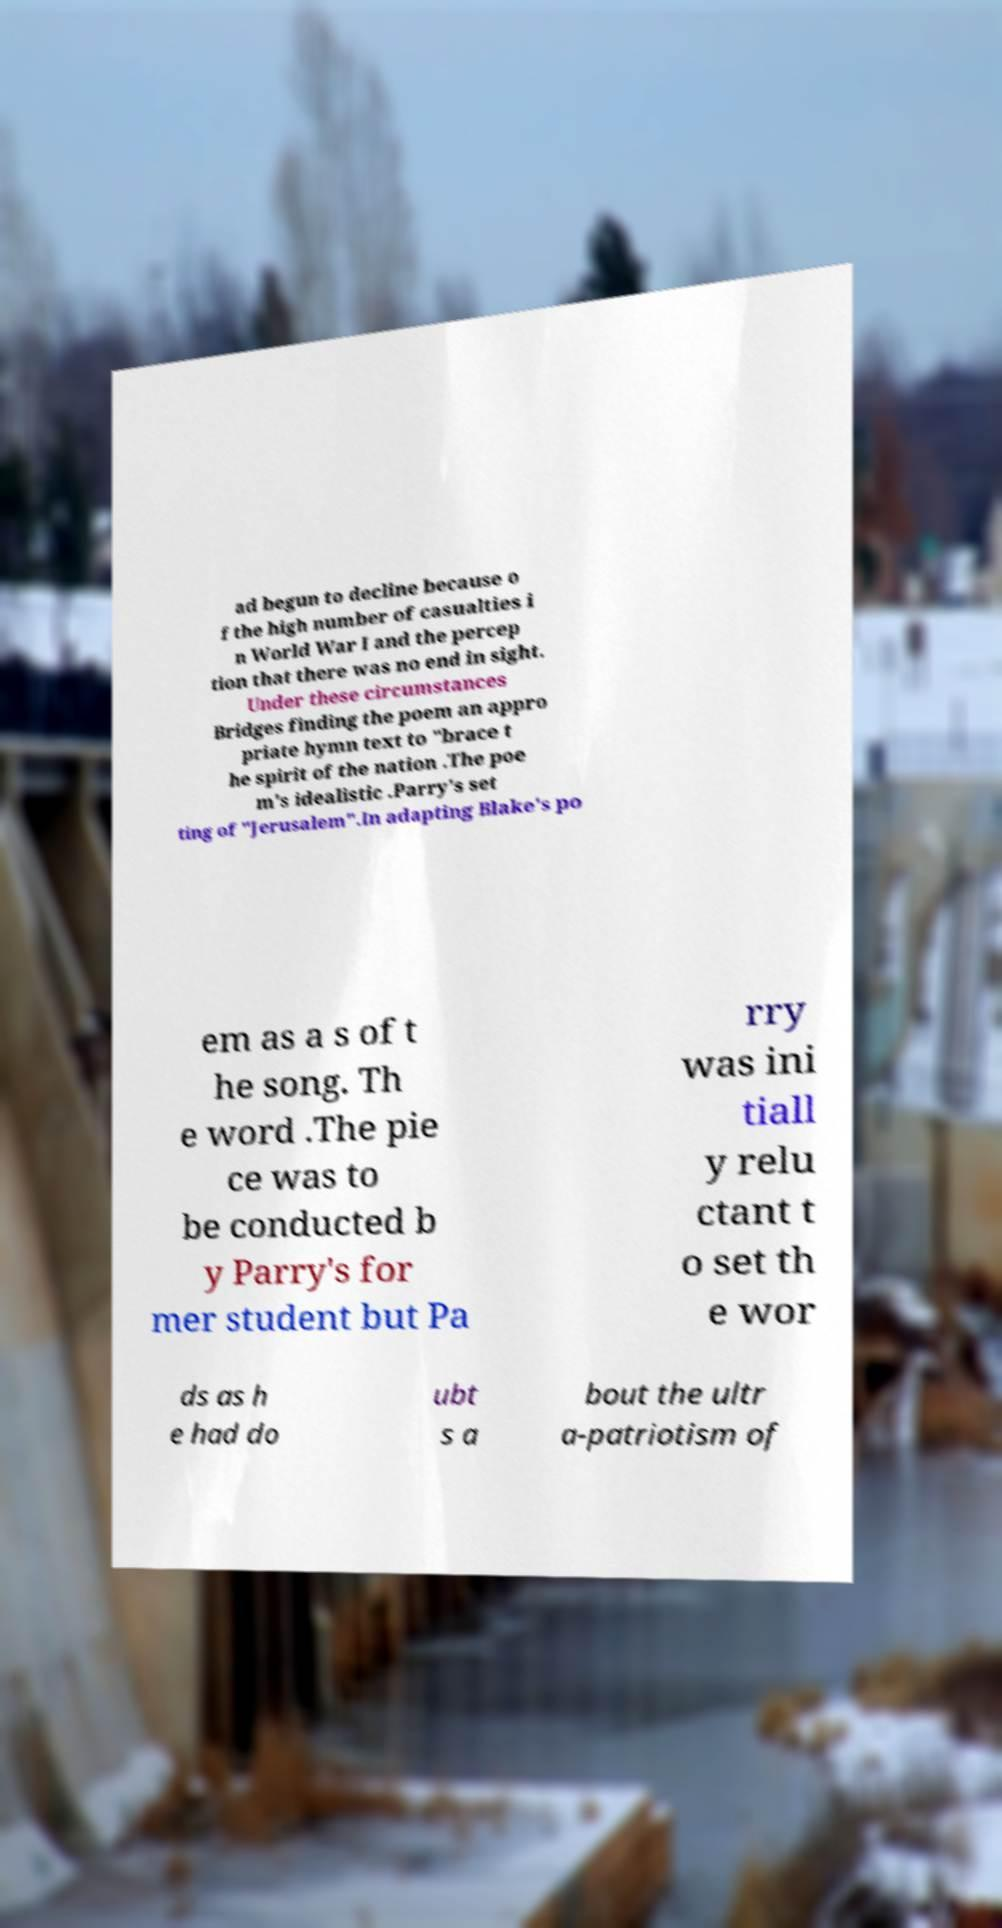Can you accurately transcribe the text from the provided image for me? ad begun to decline because o f the high number of casualties i n World War I and the percep tion that there was no end in sight. Under these circumstances Bridges finding the poem an appro priate hymn text to "brace t he spirit of the nation .The poe m's idealistic .Parry's set ting of "Jerusalem".In adapting Blake's po em as a s of t he song. Th e word .The pie ce was to be conducted b y Parry's for mer student but Pa rry was ini tiall y relu ctant t o set th e wor ds as h e had do ubt s a bout the ultr a-patriotism of 